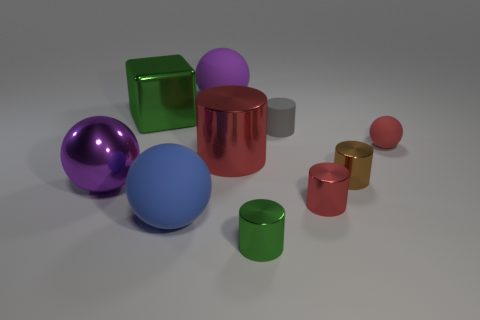What is the size of the thing that is the same color as the metallic sphere?
Your answer should be very brief. Large. What number of small metal cylinders are the same color as the metallic cube?
Your answer should be compact. 1. What number of balls are purple matte objects or big green things?
Keep it short and to the point. 1. There is another rubber cylinder that is the same size as the green cylinder; what is its color?
Provide a short and direct response. Gray. There is a purple object that is on the left side of the large matte object that is behind the gray cylinder; are there any red metallic things that are behind it?
Your answer should be very brief. Yes. The purple metallic ball has what size?
Keep it short and to the point. Large. How many things are either brown metal cylinders or small metal cylinders?
Offer a terse response. 3. What color is the big ball that is the same material as the big cube?
Your response must be concise. Purple. Is the shape of the purple thing in front of the gray object the same as  the large blue rubber object?
Your response must be concise. Yes. How many things are either big purple spheres on the left side of the large green metallic object or shiny objects on the right side of the tiny gray matte cylinder?
Your answer should be compact. 3. 